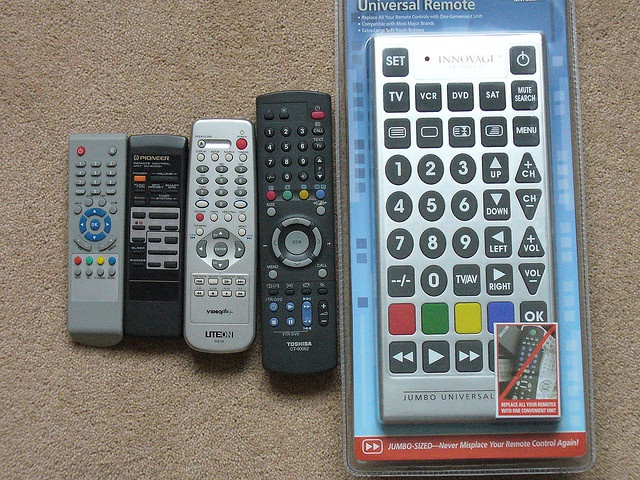Describe the objects in this image and their specific colors. I can see remote in tan, white, purple, darkgray, and teal tones, remote in tan, black, and gray tones, remote in tan, black, gray, and purple tones, and remote in tan, darkgray, gray, lightgray, and black tones in this image. 